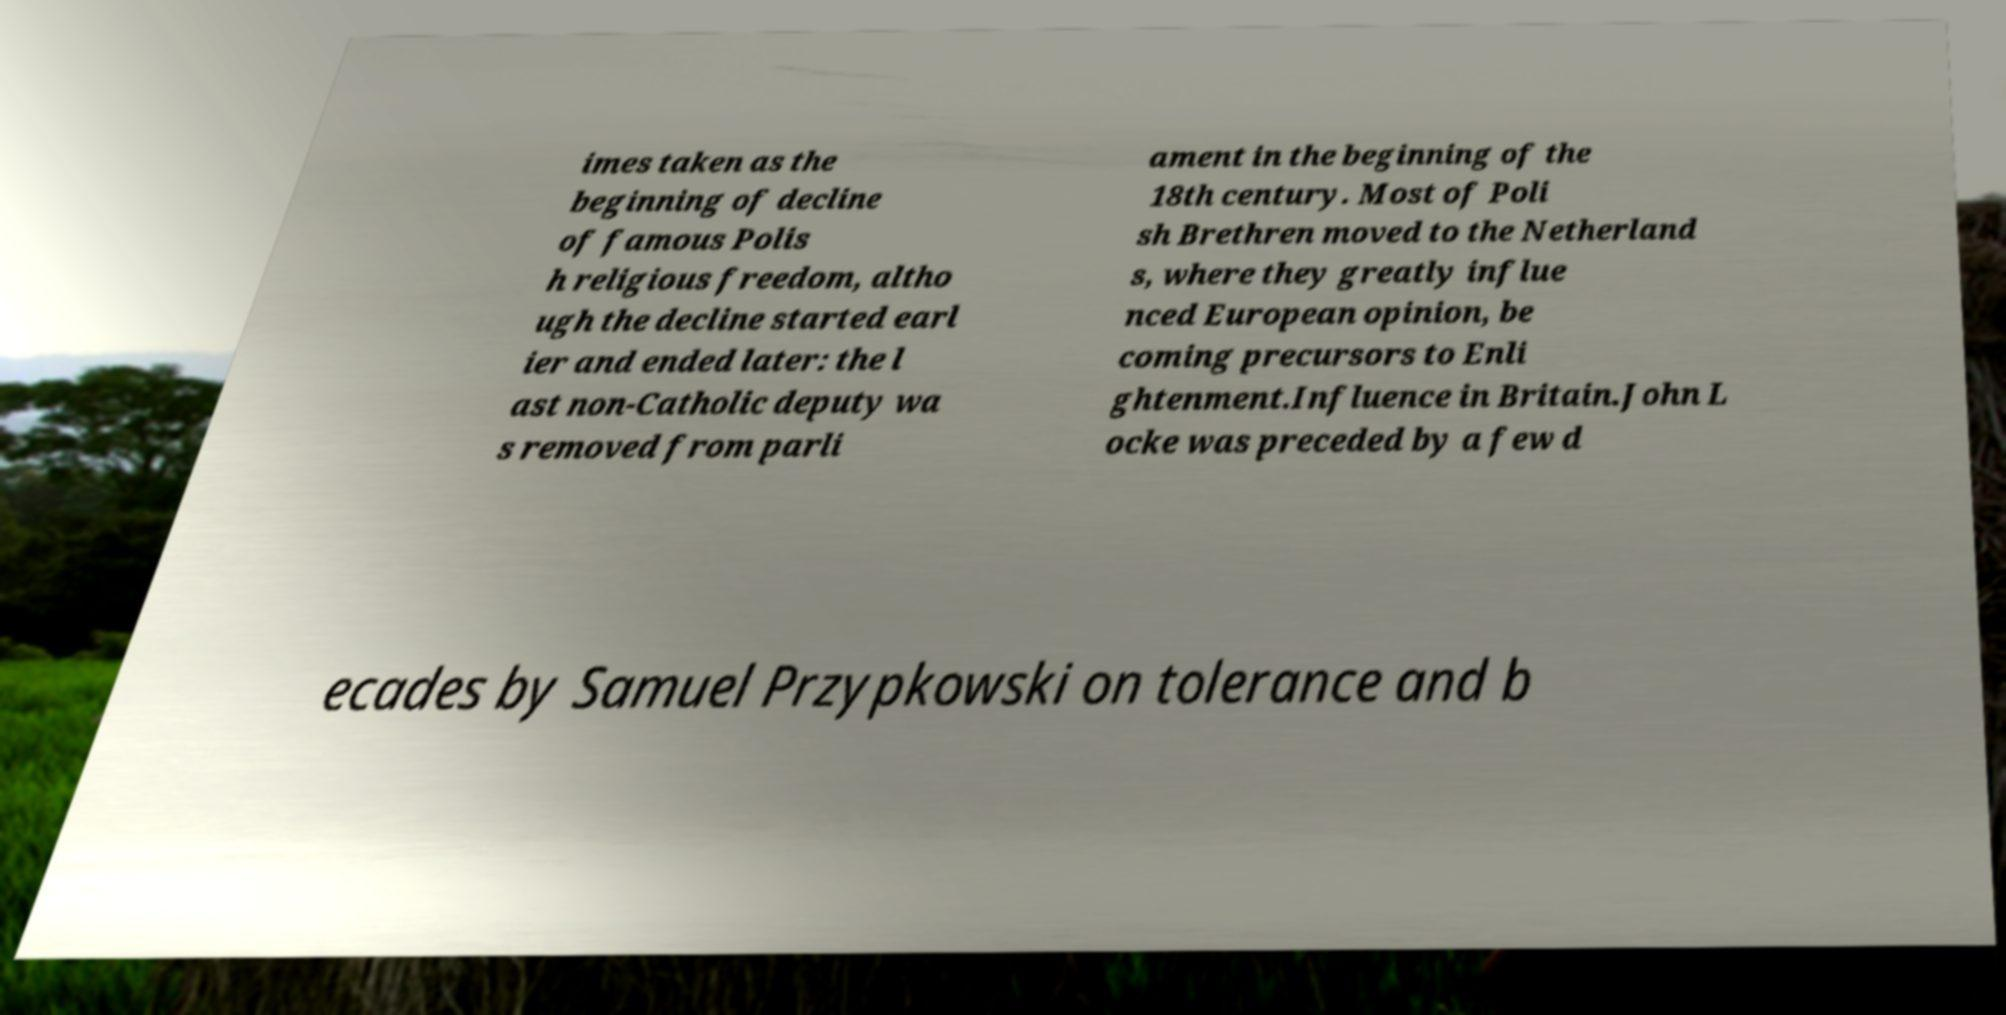Can you read and provide the text displayed in the image?This photo seems to have some interesting text. Can you extract and type it out for me? imes taken as the beginning of decline of famous Polis h religious freedom, altho ugh the decline started earl ier and ended later: the l ast non-Catholic deputy wa s removed from parli ament in the beginning of the 18th century. Most of Poli sh Brethren moved to the Netherland s, where they greatly influe nced European opinion, be coming precursors to Enli ghtenment.Influence in Britain.John L ocke was preceded by a few d ecades by Samuel Przypkowski on tolerance and b 